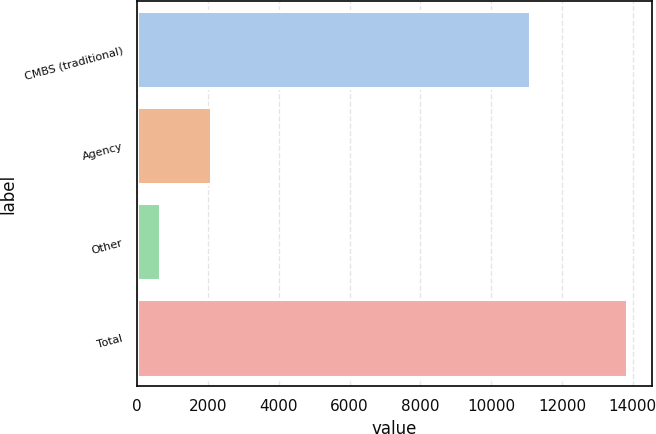<chart> <loc_0><loc_0><loc_500><loc_500><bar_chart><fcel>CMBS (traditional)<fcel>Agency<fcel>Other<fcel>Total<nl><fcel>11092<fcel>2093<fcel>656<fcel>13841<nl></chart> 